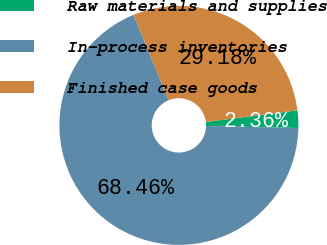<chart> <loc_0><loc_0><loc_500><loc_500><pie_chart><fcel>Raw materials and supplies<fcel>In-process inventories<fcel>Finished case goods<nl><fcel>2.36%<fcel>68.46%<fcel>29.18%<nl></chart> 